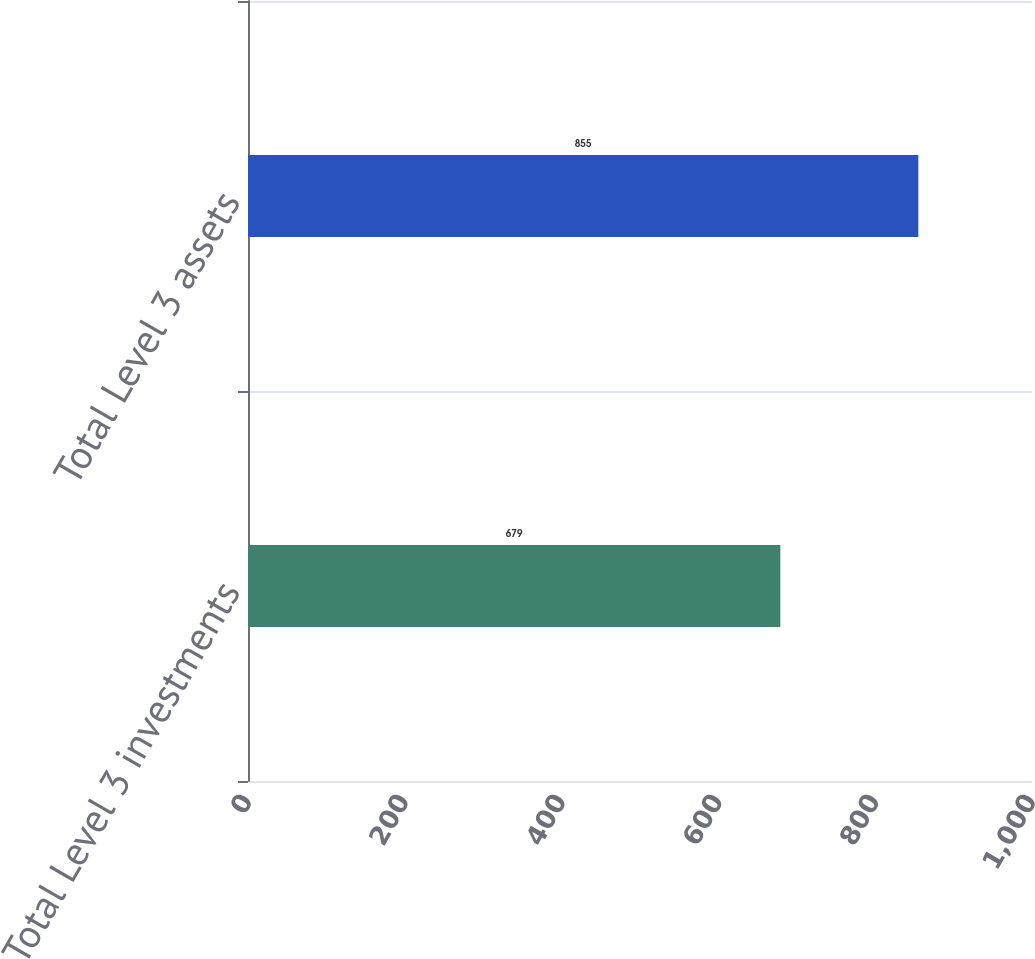<chart> <loc_0><loc_0><loc_500><loc_500><bar_chart><fcel>Total Level 3 investments<fcel>Total Level 3 assets<nl><fcel>679<fcel>855<nl></chart> 